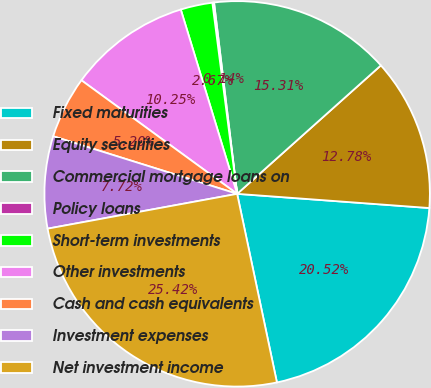<chart> <loc_0><loc_0><loc_500><loc_500><pie_chart><fcel>Fixed maturities<fcel>Equity securities<fcel>Commercial mortgage loans on<fcel>Policy loans<fcel>Short-term investments<fcel>Other investments<fcel>Cash and cash equivalents<fcel>Investment expenses<fcel>Net investment income<nl><fcel>20.52%<fcel>12.78%<fcel>15.31%<fcel>0.14%<fcel>2.67%<fcel>10.25%<fcel>5.2%<fcel>7.72%<fcel>25.42%<nl></chart> 